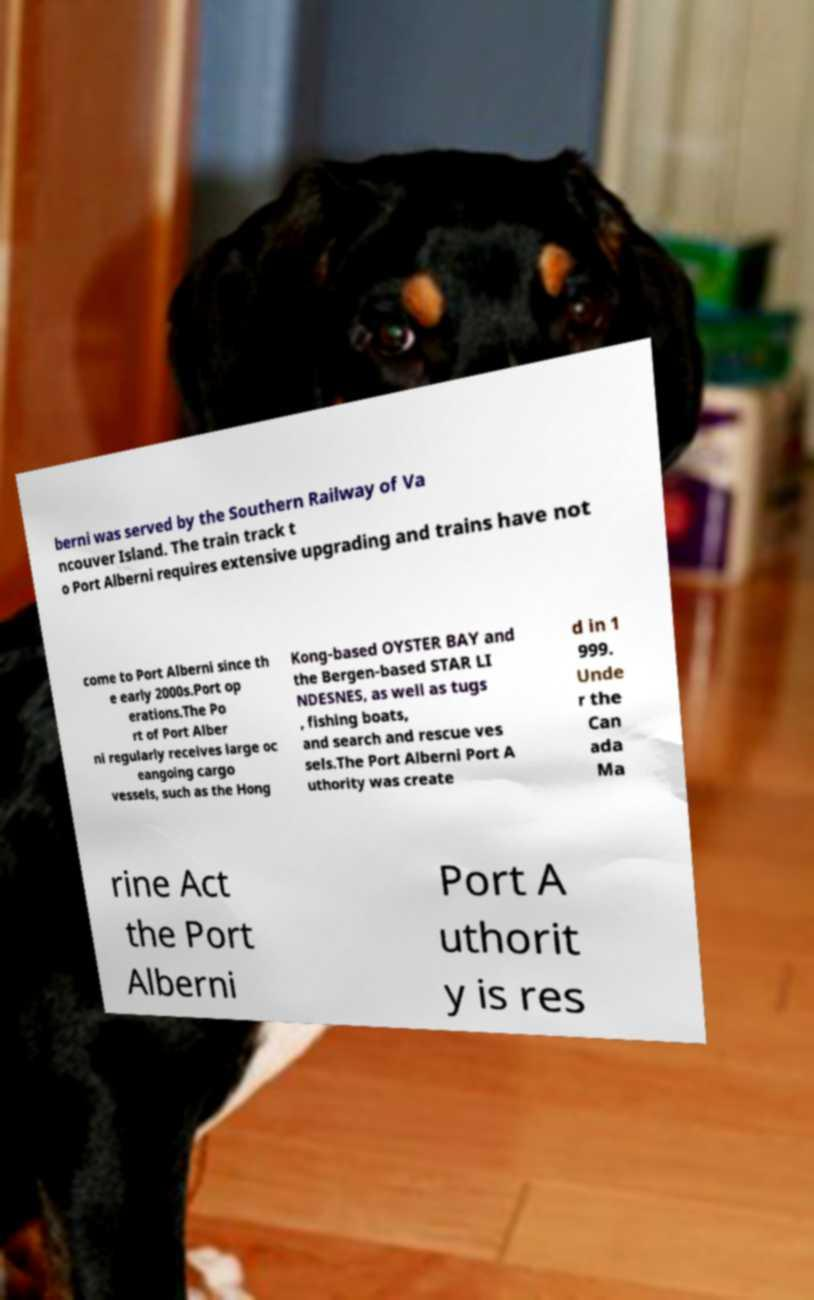Please identify and transcribe the text found in this image. berni was served by the Southern Railway of Va ncouver Island. The train track t o Port Alberni requires extensive upgrading and trains have not come to Port Alberni since th e early 2000s.Port op erations.The Po rt of Port Alber ni regularly receives large oc eangoing cargo vessels, such as the Hong Kong-based OYSTER BAY and the Bergen-based STAR LI NDESNES, as well as tugs , fishing boats, and search and rescue ves sels.The Port Alberni Port A uthority was create d in 1 999. Unde r the Can ada Ma rine Act the Port Alberni Port A uthorit y is res 